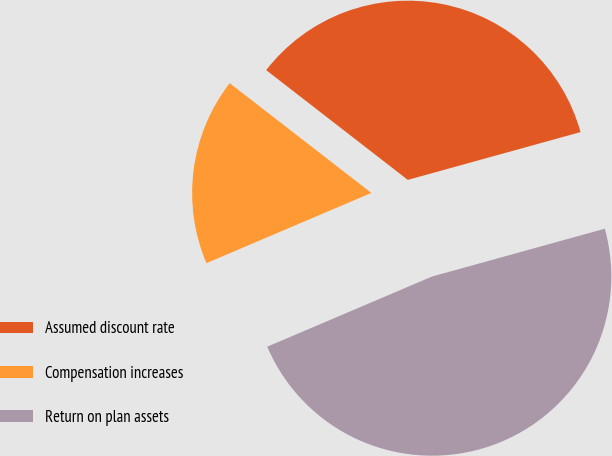Convert chart to OTSL. <chart><loc_0><loc_0><loc_500><loc_500><pie_chart><fcel>Assumed discount rate<fcel>Compensation increases<fcel>Return on plan assets<nl><fcel>35.21%<fcel>16.9%<fcel>47.89%<nl></chart> 